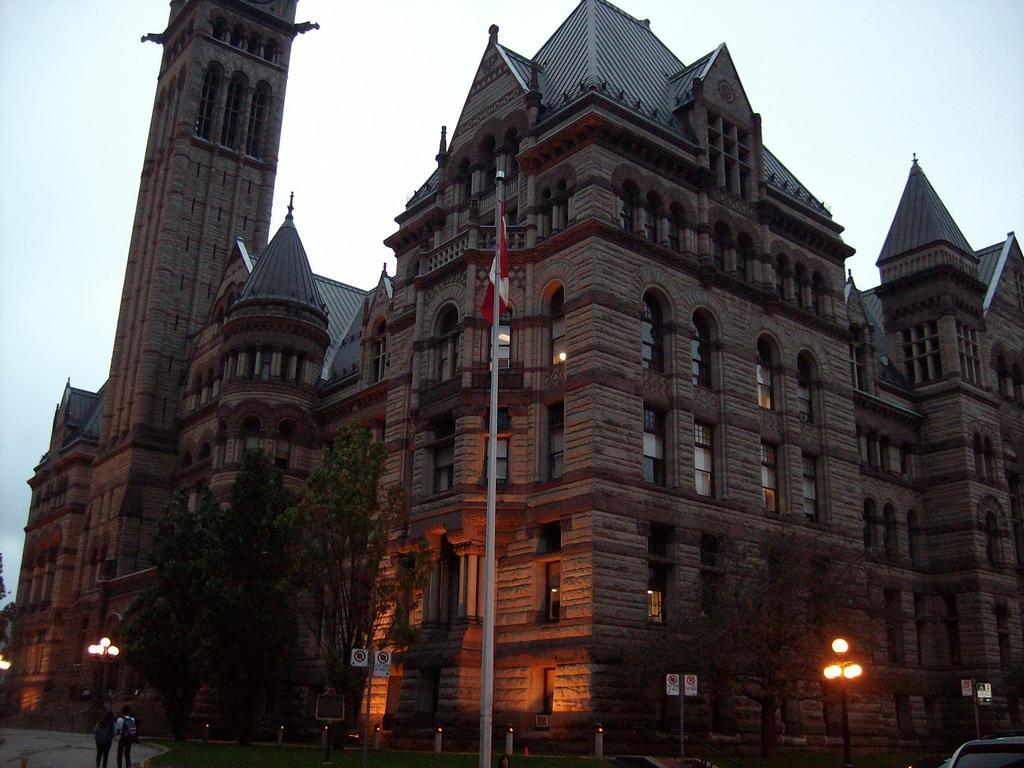How would you summarize this image in a sentence or two? In this image there is a tall building in the middle. In front of the building there is a flag post to which there is a flag. At the bottom there are lights and a tree. At the top there is the sky. 